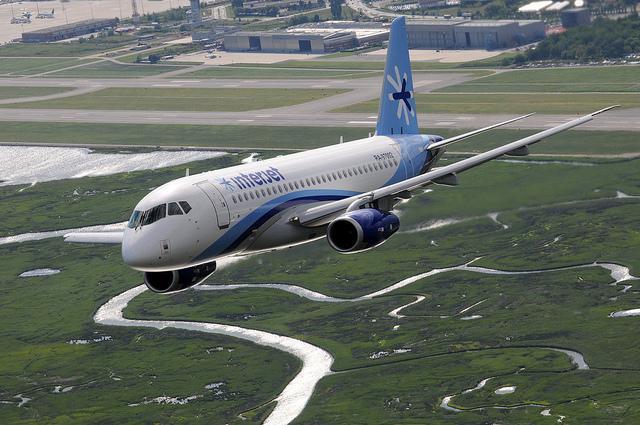How many planes are there?
Give a very brief answer. 1. 